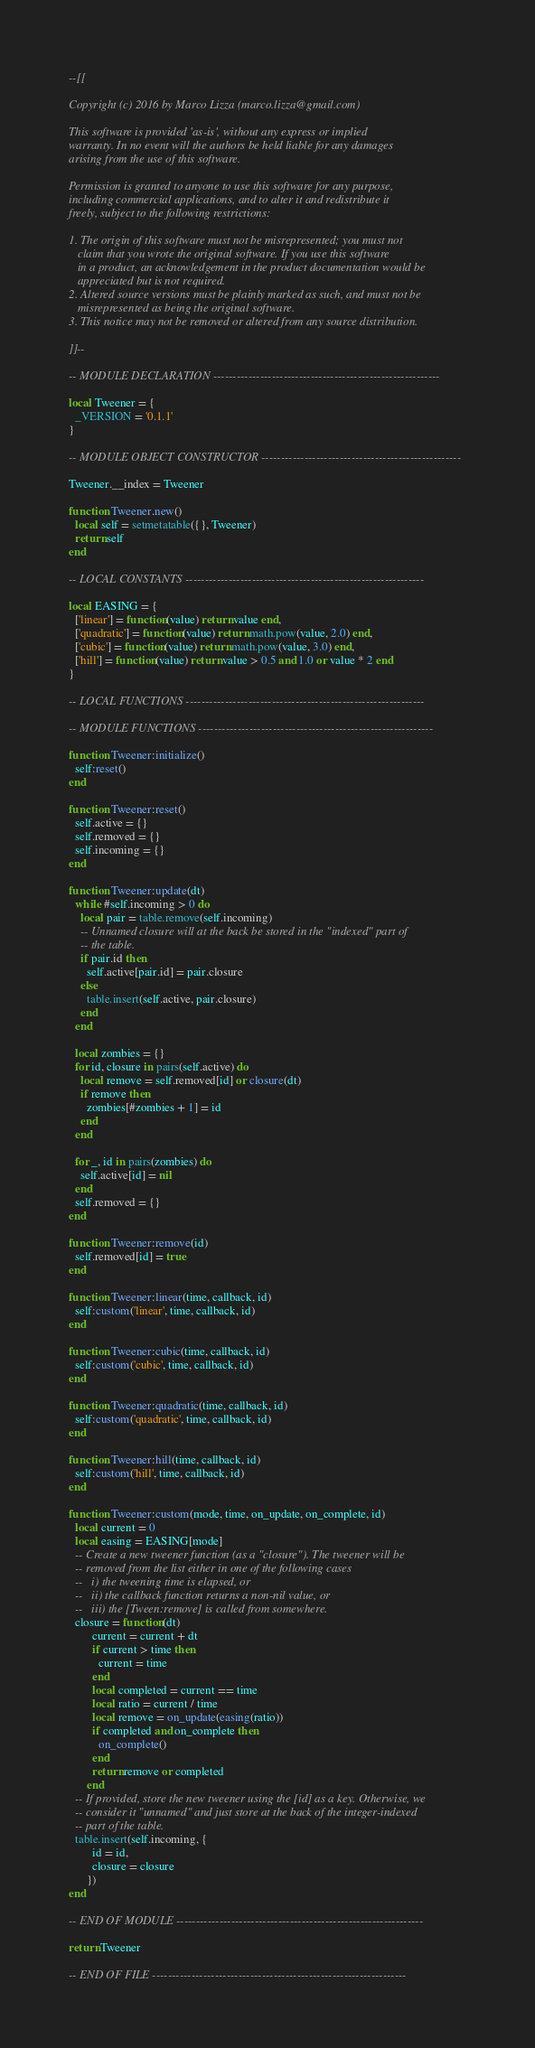<code> <loc_0><loc_0><loc_500><loc_500><_Lua_>--[[

Copyright (c) 2016 by Marco Lizza (marco.lizza@gmail.com)

This software is provided 'as-is', without any express or implied
warranty. In no event will the authors be held liable for any damages
arising from the use of this software.

Permission is granted to anyone to use this software for any purpose,
including commercial applications, and to alter it and redistribute it
freely, subject to the following restrictions:

1. The origin of this software must not be misrepresented; you must not
   claim that you wrote the original software. If you use this software
   in a product, an acknowledgement in the product documentation would be
   appreciated but is not required.
2. Altered source versions must be plainly marked as such, and must not be
   misrepresented as being the original software.
3. This notice may not be removed or altered from any source distribution.

]]--

-- MODULE DECLARATION ----------------------------------------------------------

local Tweener = {
  _VERSION = '0.1.1'
}

-- MODULE OBJECT CONSTRUCTOR ---------------------------------------------------

Tweener.__index = Tweener

function Tweener.new()
  local self = setmetatable({}, Tweener)
  return self
end

-- LOCAL CONSTANTS -------------------------------------------------------------

local EASING = {
  ['linear'] = function(value) return value end,
  ['quadratic'] = function(value) return math.pow(value, 2.0) end,
  ['cubic'] = function(value) return math.pow(value, 3.0) end,
  ['hill'] = function(value) return value > 0.5 and 1.0 or value * 2 end
}

-- LOCAL FUNCTIONS -------------------------------------------------------------

-- MODULE FUNCTIONS ------------------------------------------------------------

function Tweener:initialize()
  self:reset()
end

function Tweener:reset()
  self.active = {}
  self.removed = {}
  self.incoming = {}
end

function Tweener:update(dt)
  while #self.incoming > 0 do
    local pair = table.remove(self.incoming)
    -- Unnamed closure will at the back be stored in the "indexed" part of
    -- the table.
    if pair.id then
      self.active[pair.id] = pair.closure
    else
      table.insert(self.active, pair.closure)
    end
  end
  
  local zombies = {}
  for id, closure in pairs(self.active) do
    local remove = self.removed[id] or closure(dt)
    if remove then
      zombies[#zombies + 1] = id
    end
  end

  for _, id in pairs(zombies) do
    self.active[id] = nil
  end
  self.removed = {}
end

function Tweener:remove(id)
  self.removed[id] = true
end

function Tweener:linear(time, callback, id)
  self:custom('linear', time, callback, id)
end

function Tweener:cubic(time, callback, id)
  self:custom('cubic', time, callback, id)
end

function Tweener:quadratic(time, callback, id)
  self:custom('quadratic', time, callback, id)
end

function Tweener:hill(time, callback, id)
  self:custom('hill', time, callback, id)
end

function Tweener:custom(mode, time, on_update, on_complete, id)
  local current = 0
  local easing = EASING[mode]
  -- Create a new tweener function (as a "closure"). The tweener will be
  -- removed from the list either in one of the following cases
  --   i) the tweening time is elapsed, or
  --   ii) the callback function returns a non-nil value, or
  --   iii) the [Tween:remove] is called from somewhere.
  closure = function(dt)
        current = current + dt
        if current > time then
          current = time
        end
        local completed = current == time
        local ratio = current / time
        local remove = on_update(easing(ratio))
        if completed and on_complete then
          on_complete()
        end
        return remove or completed
      end
  -- If provided, store the new tweener using the [id] as a key. Otherwise, we
  -- consider it "unnamed" and just store at the back of the integer-indexed
  -- part of the table.
  table.insert(self.incoming, {
        id = id,
        closure = closure
      })
end

-- END OF MODULE ---------------------------------------------------------------

return Tweener

-- END OF FILE -----------------------------------------------------------------
</code> 